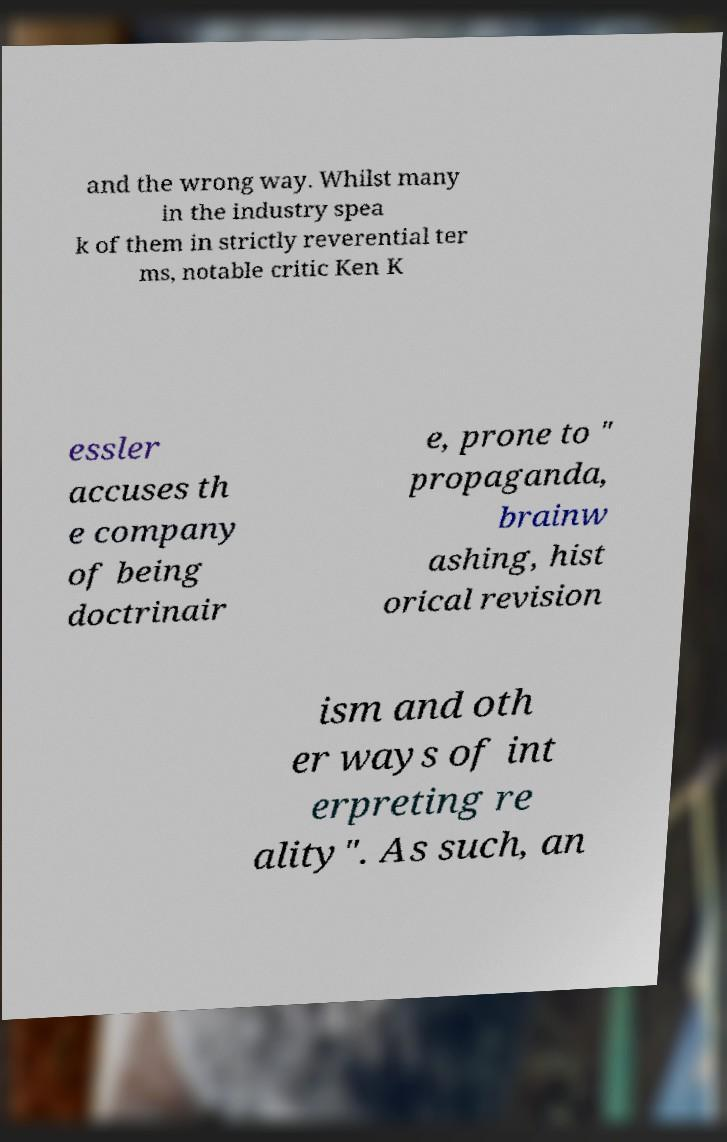Could you extract and type out the text from this image? and the wrong way. Whilst many in the industry spea k of them in strictly reverential ter ms, notable critic Ken K essler accuses th e company of being doctrinair e, prone to " propaganda, brainw ashing, hist orical revision ism and oth er ways of int erpreting re ality". As such, an 